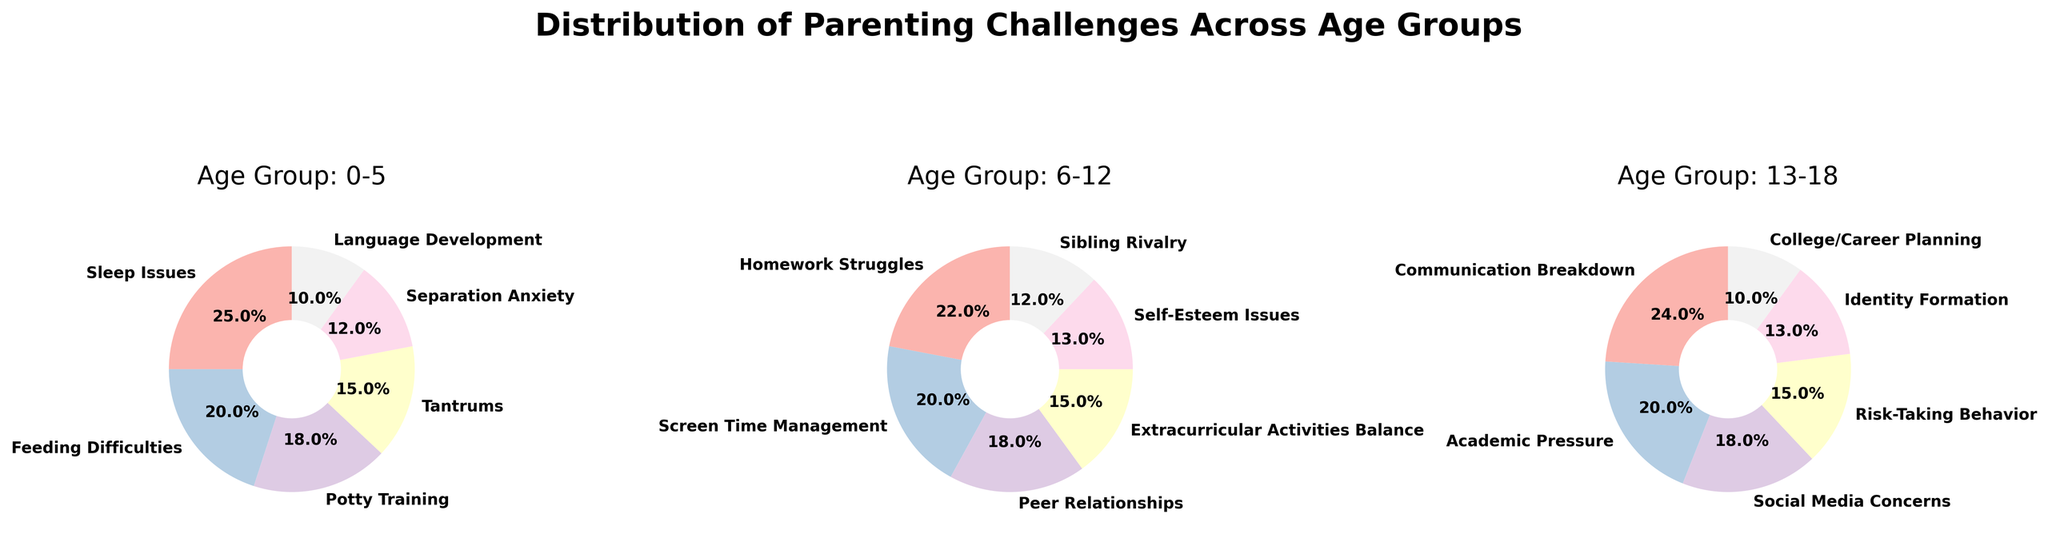What's the most common parenting challenge in the 0-5 age group? The pie chart for the 0-5 age group, identified by the title "Age Group: 0-5", shows that "Sleep Issues" have the largest segment, indicating it is the most common challenge, contributing to 25% of the total.
Answer: Sleep Issues Which age group has the highest percentage for "Academic Pressure"? In the pie chart for the 13-18 age group, the segment for "Academic Pressure" shows 20%, which is not present in the other two age groups' pie charts.
Answer: 13-18 What is the combined percentage for "Peer Relationships" and "Self-Esteem Issues" in the 6-12 age group? 'Peer Relationships' has 18% and 'Self-Esteem Issues' has 13%. Summing them gives 18 + 13 = 31%.
Answer: 31% Which parenting challenge is common across all age groups? Reviewing each pie chart, no single challenge appears in all three age groups; challenges differ based on age-specific issues.
Answer: None In the 0-5 age group, how much larger is the segment for "Tantrums" compared to "Language Development"? "Tantrums" represents 15%, whereas "Language Development" accounts for 10%. The difference is 15 - 10 = 5%.
Answer: 5% Among "Screen Time Management" in 6-12 and "Social Media Concerns" in 13-18, which has the higher percentage? "Screen Time Management" in the 6-12 age group accounts for 20%, whereas "Social Media Concerns" in the 13-18 age group represents 18%. Therefore, "Screen Time Management" is higher.
Answer: Screen Time Management What is the total percentage of challenges related to emotional well-being in the 13-18 age group ("Self-Esteem Issues" and "Identity Formation")? Neither "Self-Esteem Issues" nor "Identity Formation" appear on the 13-18 pie chart explicitly. For more accuracy in percentages, one needs to check the 6-12 chart instead.
Answer: NA Which challenge occupies the smallest segment in the 0-5 age group? The pie chart for the 0-5 age group shows that "Language Development" has the smallest segment with 10%.
Answer: Language Development Comparing "Risk-Taking Behavior" in 13-18 and "Separation Anxiety" in 0-5, which one is larger? "Risk-Taking Behavior" in the 13-18 age group is 15%, whereas "Separation Anxiety" in the 0-5 age group is 12%. "Risk-Taking Behavior" is larger.
Answer: Risk-Taking Behavior 